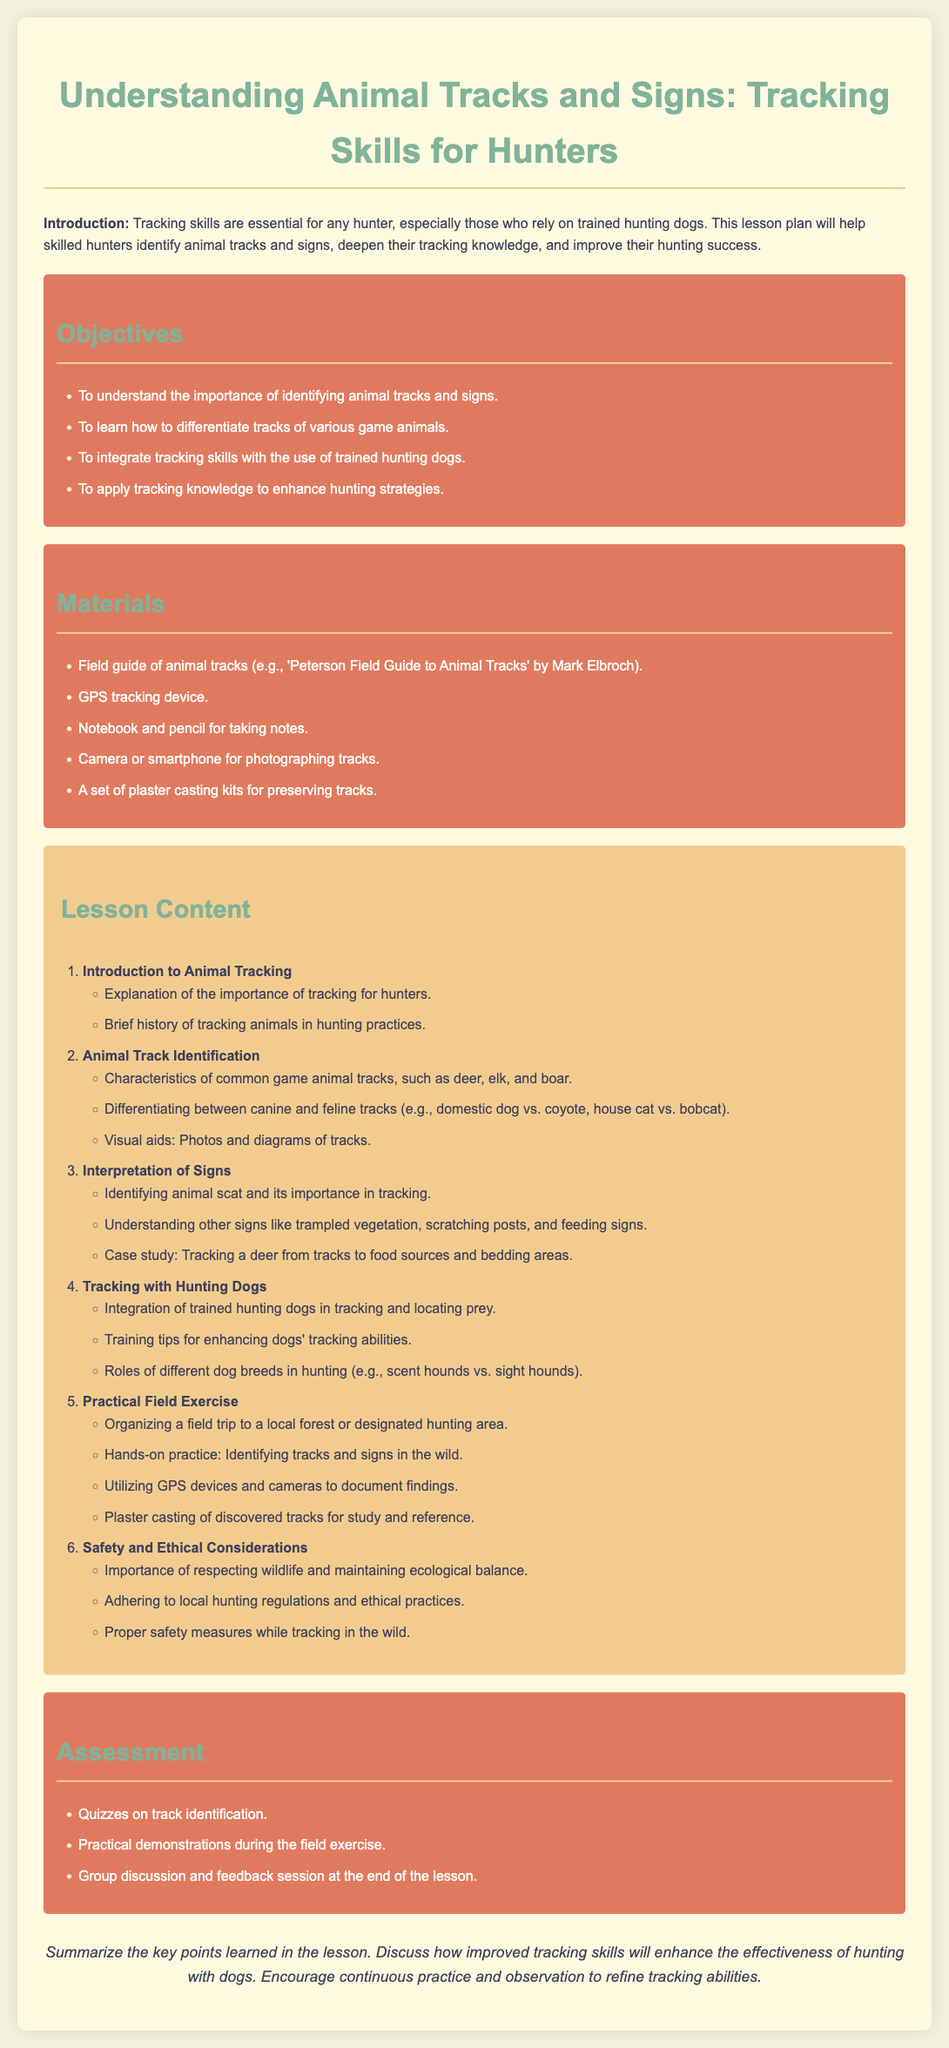what is the title of the lesson plan? The title of the lesson plan is presented in the header section of the document.
Answer: Understanding Animal Tracks and Signs: Tracking Skills for Hunters what are the main objectives of the lesson? The objectives are listed under a specific section titled "Objectives" in the document.
Answer: To understand the importance of identifying animal tracks and signs, to learn how to differentiate tracks of various game animals, to integrate tracking skills with the use of trained hunting dogs, to apply tracking knowledge to enhance hunting strategies how many materials are listed in the lesson plan? The number of materials is indicated in the section titled "Materials."
Answer: Five which animal tracks are being differentiated in the lesson? The specific animal tracks mentioned in the document are provided under a section related to track identification.
Answer: Canine and feline tracks what is the importance of animal scat in tracking? The importance of animal scat is described in a section focused on interpreting signs.
Answer: Identifying animal scat and its importance in tracking what is included in the practical field exercise? The details of the practical field exercise can be found in the section labeled "Practical Field Exercise."
Answer: Identifying tracks and signs in the wild what is the final assessment method mentioned in the document? The final assessment method is referenced in the section titled "Assessment."
Answer: Group discussion and feedback session at the end of the lesson 